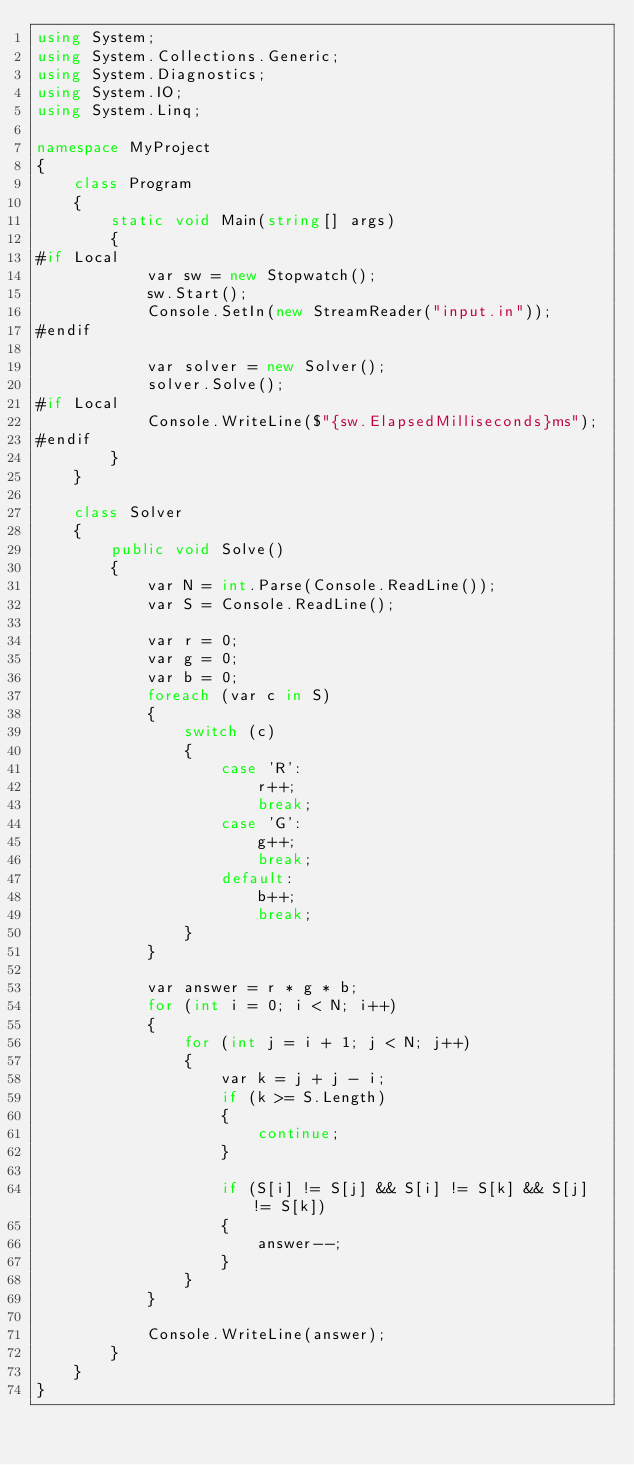<code> <loc_0><loc_0><loc_500><loc_500><_C#_>using System;
using System.Collections.Generic;
using System.Diagnostics;
using System.IO;
using System.Linq;

namespace MyProject
{
    class Program
    {
        static void Main(string[] args)
        {
#if Local
            var sw = new Stopwatch();
            sw.Start();
            Console.SetIn(new StreamReader("input.in"));
#endif

            var solver = new Solver();
            solver.Solve();
#if Local
            Console.WriteLine($"{sw.ElapsedMilliseconds}ms");
#endif
        }
    }

    class Solver
    {
        public void Solve()
        {
            var N = int.Parse(Console.ReadLine());
            var S = Console.ReadLine();

            var r = 0;
            var g = 0;
            var b = 0;
            foreach (var c in S)
            {
                switch (c)
                {
                    case 'R':
                        r++;
                        break;
                    case 'G':
                        g++;
                        break;
                    default:
                        b++;
                        break;
                }
            }

            var answer = r * g * b;
            for (int i = 0; i < N; i++)
            {
                for (int j = i + 1; j < N; j++)
                {
                    var k = j + j - i;
                    if (k >= S.Length)
                    {
                        continue;
                    }

                    if (S[i] != S[j] && S[i] != S[k] && S[j] != S[k])
                    {
                        answer--;
                    }
                }
            }

            Console.WriteLine(answer);
        }
    }
}
</code> 